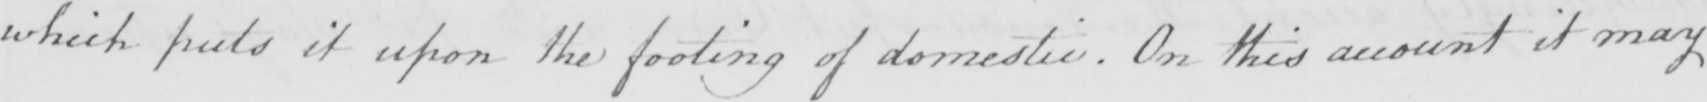Please transcribe the handwritten text in this image. which puts it upon the footing of domestic  . On this account it may 